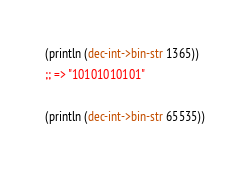Convert code to text. <code><loc_0><loc_0><loc_500><loc_500><_Clojure_>(println (dec-int->bin-str 1365))
;; => "10101010101"

(println (dec-int->bin-str 65535))</code> 